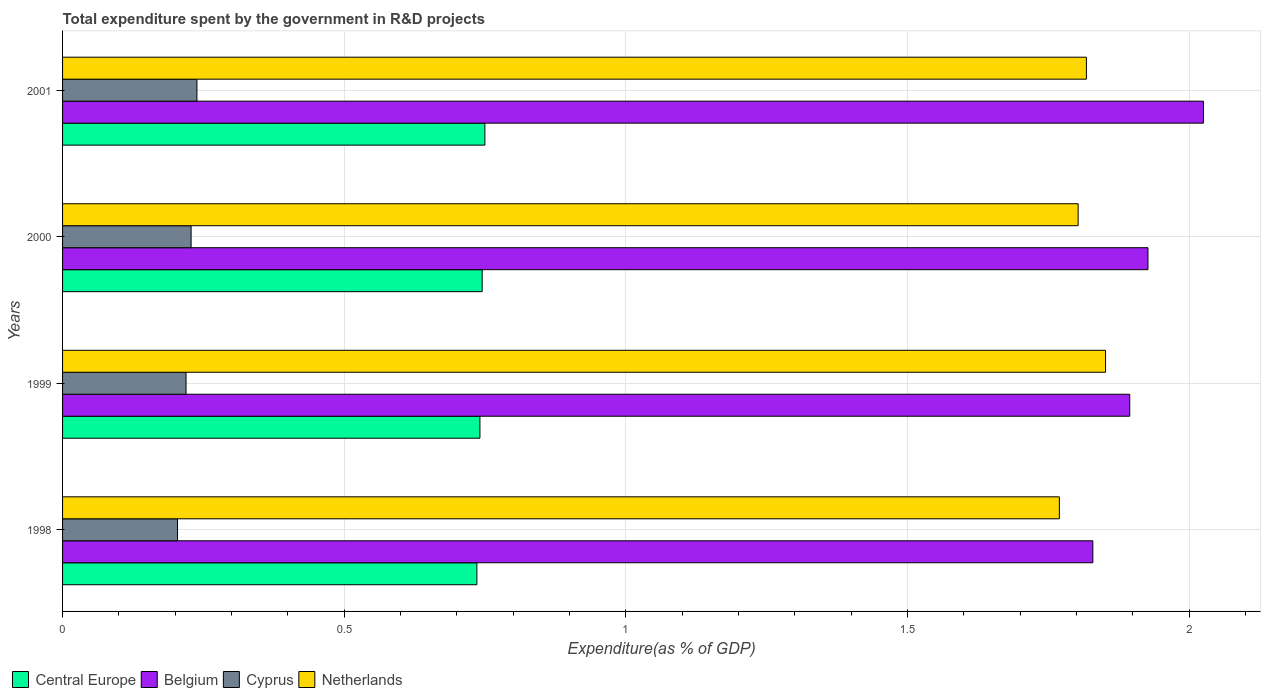Are the number of bars on each tick of the Y-axis equal?
Ensure brevity in your answer.  Yes. How many bars are there on the 3rd tick from the top?
Your answer should be very brief. 4. How many bars are there on the 1st tick from the bottom?
Your answer should be very brief. 4. What is the label of the 1st group of bars from the top?
Keep it short and to the point. 2001. In how many cases, is the number of bars for a given year not equal to the number of legend labels?
Ensure brevity in your answer.  0. What is the total expenditure spent by the government in R&D projects in Belgium in 2001?
Offer a terse response. 2.03. Across all years, what is the maximum total expenditure spent by the government in R&D projects in Netherlands?
Give a very brief answer. 1.85. Across all years, what is the minimum total expenditure spent by the government in R&D projects in Belgium?
Offer a very short reply. 1.83. What is the total total expenditure spent by the government in R&D projects in Belgium in the graph?
Ensure brevity in your answer.  7.68. What is the difference between the total expenditure spent by the government in R&D projects in Netherlands in 2000 and that in 2001?
Keep it short and to the point. -0.01. What is the difference between the total expenditure spent by the government in R&D projects in Cyprus in 1998 and the total expenditure spent by the government in R&D projects in Belgium in 1999?
Your response must be concise. -1.69. What is the average total expenditure spent by the government in R&D projects in Cyprus per year?
Your answer should be compact. 0.22. In the year 2001, what is the difference between the total expenditure spent by the government in R&D projects in Cyprus and total expenditure spent by the government in R&D projects in Belgium?
Your response must be concise. -1.79. In how many years, is the total expenditure spent by the government in R&D projects in Cyprus greater than 0.4 %?
Provide a succinct answer. 0. What is the ratio of the total expenditure spent by the government in R&D projects in Central Europe in 1998 to that in 1999?
Make the answer very short. 0.99. Is the total expenditure spent by the government in R&D projects in Central Europe in 1998 less than that in 1999?
Keep it short and to the point. Yes. Is the difference between the total expenditure spent by the government in R&D projects in Cyprus in 1998 and 2000 greater than the difference between the total expenditure spent by the government in R&D projects in Belgium in 1998 and 2000?
Ensure brevity in your answer.  Yes. What is the difference between the highest and the second highest total expenditure spent by the government in R&D projects in Cyprus?
Provide a succinct answer. 0.01. What is the difference between the highest and the lowest total expenditure spent by the government in R&D projects in Central Europe?
Your answer should be very brief. 0.01. In how many years, is the total expenditure spent by the government in R&D projects in Netherlands greater than the average total expenditure spent by the government in R&D projects in Netherlands taken over all years?
Ensure brevity in your answer.  2. Is the sum of the total expenditure spent by the government in R&D projects in Belgium in 1998 and 2000 greater than the maximum total expenditure spent by the government in R&D projects in Cyprus across all years?
Your answer should be very brief. Yes. What does the 4th bar from the top in 2000 represents?
Make the answer very short. Central Europe. What does the 2nd bar from the bottom in 1998 represents?
Keep it short and to the point. Belgium. How many bars are there?
Keep it short and to the point. 16. Does the graph contain any zero values?
Your response must be concise. No. Does the graph contain grids?
Offer a very short reply. Yes. Where does the legend appear in the graph?
Provide a succinct answer. Bottom left. What is the title of the graph?
Provide a succinct answer. Total expenditure spent by the government in R&D projects. Does "Central African Republic" appear as one of the legend labels in the graph?
Provide a succinct answer. No. What is the label or title of the X-axis?
Make the answer very short. Expenditure(as % of GDP). What is the label or title of the Y-axis?
Keep it short and to the point. Years. What is the Expenditure(as % of GDP) in Central Europe in 1998?
Your answer should be compact. 0.74. What is the Expenditure(as % of GDP) of Belgium in 1998?
Offer a terse response. 1.83. What is the Expenditure(as % of GDP) in Cyprus in 1998?
Offer a terse response. 0.2. What is the Expenditure(as % of GDP) of Netherlands in 1998?
Keep it short and to the point. 1.77. What is the Expenditure(as % of GDP) in Central Europe in 1999?
Your answer should be compact. 0.74. What is the Expenditure(as % of GDP) of Belgium in 1999?
Your answer should be compact. 1.89. What is the Expenditure(as % of GDP) in Cyprus in 1999?
Ensure brevity in your answer.  0.22. What is the Expenditure(as % of GDP) in Netherlands in 1999?
Your answer should be compact. 1.85. What is the Expenditure(as % of GDP) of Central Europe in 2000?
Ensure brevity in your answer.  0.74. What is the Expenditure(as % of GDP) in Belgium in 2000?
Provide a succinct answer. 1.93. What is the Expenditure(as % of GDP) in Cyprus in 2000?
Offer a terse response. 0.23. What is the Expenditure(as % of GDP) in Netherlands in 2000?
Offer a very short reply. 1.8. What is the Expenditure(as % of GDP) of Central Europe in 2001?
Your answer should be very brief. 0.75. What is the Expenditure(as % of GDP) of Belgium in 2001?
Provide a short and direct response. 2.03. What is the Expenditure(as % of GDP) in Cyprus in 2001?
Your answer should be compact. 0.24. What is the Expenditure(as % of GDP) in Netherlands in 2001?
Give a very brief answer. 1.82. Across all years, what is the maximum Expenditure(as % of GDP) of Central Europe?
Offer a terse response. 0.75. Across all years, what is the maximum Expenditure(as % of GDP) of Belgium?
Ensure brevity in your answer.  2.03. Across all years, what is the maximum Expenditure(as % of GDP) of Cyprus?
Make the answer very short. 0.24. Across all years, what is the maximum Expenditure(as % of GDP) in Netherlands?
Your response must be concise. 1.85. Across all years, what is the minimum Expenditure(as % of GDP) of Central Europe?
Keep it short and to the point. 0.74. Across all years, what is the minimum Expenditure(as % of GDP) in Belgium?
Provide a succinct answer. 1.83. Across all years, what is the minimum Expenditure(as % of GDP) of Cyprus?
Your answer should be very brief. 0.2. Across all years, what is the minimum Expenditure(as % of GDP) in Netherlands?
Ensure brevity in your answer.  1.77. What is the total Expenditure(as % of GDP) of Central Europe in the graph?
Your answer should be compact. 2.97. What is the total Expenditure(as % of GDP) of Belgium in the graph?
Offer a terse response. 7.68. What is the total Expenditure(as % of GDP) of Cyprus in the graph?
Your response must be concise. 0.89. What is the total Expenditure(as % of GDP) of Netherlands in the graph?
Make the answer very short. 7.24. What is the difference between the Expenditure(as % of GDP) in Central Europe in 1998 and that in 1999?
Your answer should be compact. -0.01. What is the difference between the Expenditure(as % of GDP) in Belgium in 1998 and that in 1999?
Your answer should be very brief. -0.07. What is the difference between the Expenditure(as % of GDP) in Cyprus in 1998 and that in 1999?
Give a very brief answer. -0.02. What is the difference between the Expenditure(as % of GDP) of Netherlands in 1998 and that in 1999?
Offer a very short reply. -0.08. What is the difference between the Expenditure(as % of GDP) in Central Europe in 1998 and that in 2000?
Your response must be concise. -0.01. What is the difference between the Expenditure(as % of GDP) in Belgium in 1998 and that in 2000?
Your answer should be compact. -0.1. What is the difference between the Expenditure(as % of GDP) in Cyprus in 1998 and that in 2000?
Your response must be concise. -0.02. What is the difference between the Expenditure(as % of GDP) of Netherlands in 1998 and that in 2000?
Make the answer very short. -0.03. What is the difference between the Expenditure(as % of GDP) in Central Europe in 1998 and that in 2001?
Your response must be concise. -0.01. What is the difference between the Expenditure(as % of GDP) of Belgium in 1998 and that in 2001?
Offer a terse response. -0.2. What is the difference between the Expenditure(as % of GDP) of Cyprus in 1998 and that in 2001?
Your answer should be very brief. -0.03. What is the difference between the Expenditure(as % of GDP) in Netherlands in 1998 and that in 2001?
Keep it short and to the point. -0.05. What is the difference between the Expenditure(as % of GDP) in Central Europe in 1999 and that in 2000?
Offer a terse response. -0. What is the difference between the Expenditure(as % of GDP) in Belgium in 1999 and that in 2000?
Offer a terse response. -0.03. What is the difference between the Expenditure(as % of GDP) in Cyprus in 1999 and that in 2000?
Ensure brevity in your answer.  -0.01. What is the difference between the Expenditure(as % of GDP) of Netherlands in 1999 and that in 2000?
Your answer should be compact. 0.05. What is the difference between the Expenditure(as % of GDP) of Central Europe in 1999 and that in 2001?
Give a very brief answer. -0.01. What is the difference between the Expenditure(as % of GDP) of Belgium in 1999 and that in 2001?
Give a very brief answer. -0.13. What is the difference between the Expenditure(as % of GDP) in Cyprus in 1999 and that in 2001?
Your response must be concise. -0.02. What is the difference between the Expenditure(as % of GDP) of Netherlands in 1999 and that in 2001?
Your answer should be very brief. 0.03. What is the difference between the Expenditure(as % of GDP) of Central Europe in 2000 and that in 2001?
Offer a very short reply. -0. What is the difference between the Expenditure(as % of GDP) in Belgium in 2000 and that in 2001?
Offer a very short reply. -0.1. What is the difference between the Expenditure(as % of GDP) in Cyprus in 2000 and that in 2001?
Offer a terse response. -0.01. What is the difference between the Expenditure(as % of GDP) in Netherlands in 2000 and that in 2001?
Give a very brief answer. -0.01. What is the difference between the Expenditure(as % of GDP) in Central Europe in 1998 and the Expenditure(as % of GDP) in Belgium in 1999?
Your answer should be compact. -1.16. What is the difference between the Expenditure(as % of GDP) of Central Europe in 1998 and the Expenditure(as % of GDP) of Cyprus in 1999?
Provide a short and direct response. 0.52. What is the difference between the Expenditure(as % of GDP) in Central Europe in 1998 and the Expenditure(as % of GDP) in Netherlands in 1999?
Your answer should be very brief. -1.12. What is the difference between the Expenditure(as % of GDP) in Belgium in 1998 and the Expenditure(as % of GDP) in Cyprus in 1999?
Your response must be concise. 1.61. What is the difference between the Expenditure(as % of GDP) in Belgium in 1998 and the Expenditure(as % of GDP) in Netherlands in 1999?
Provide a succinct answer. -0.02. What is the difference between the Expenditure(as % of GDP) of Cyprus in 1998 and the Expenditure(as % of GDP) of Netherlands in 1999?
Give a very brief answer. -1.65. What is the difference between the Expenditure(as % of GDP) in Central Europe in 1998 and the Expenditure(as % of GDP) in Belgium in 2000?
Your answer should be compact. -1.19. What is the difference between the Expenditure(as % of GDP) in Central Europe in 1998 and the Expenditure(as % of GDP) in Cyprus in 2000?
Ensure brevity in your answer.  0.51. What is the difference between the Expenditure(as % of GDP) in Central Europe in 1998 and the Expenditure(as % of GDP) in Netherlands in 2000?
Give a very brief answer. -1.07. What is the difference between the Expenditure(as % of GDP) of Belgium in 1998 and the Expenditure(as % of GDP) of Cyprus in 2000?
Ensure brevity in your answer.  1.6. What is the difference between the Expenditure(as % of GDP) in Belgium in 1998 and the Expenditure(as % of GDP) in Netherlands in 2000?
Give a very brief answer. 0.03. What is the difference between the Expenditure(as % of GDP) in Cyprus in 1998 and the Expenditure(as % of GDP) in Netherlands in 2000?
Ensure brevity in your answer.  -1.6. What is the difference between the Expenditure(as % of GDP) of Central Europe in 1998 and the Expenditure(as % of GDP) of Belgium in 2001?
Offer a terse response. -1.29. What is the difference between the Expenditure(as % of GDP) in Central Europe in 1998 and the Expenditure(as % of GDP) in Cyprus in 2001?
Provide a succinct answer. 0.5. What is the difference between the Expenditure(as % of GDP) in Central Europe in 1998 and the Expenditure(as % of GDP) in Netherlands in 2001?
Offer a terse response. -1.08. What is the difference between the Expenditure(as % of GDP) of Belgium in 1998 and the Expenditure(as % of GDP) of Cyprus in 2001?
Your response must be concise. 1.59. What is the difference between the Expenditure(as % of GDP) of Belgium in 1998 and the Expenditure(as % of GDP) of Netherlands in 2001?
Make the answer very short. 0.01. What is the difference between the Expenditure(as % of GDP) of Cyprus in 1998 and the Expenditure(as % of GDP) of Netherlands in 2001?
Make the answer very short. -1.61. What is the difference between the Expenditure(as % of GDP) in Central Europe in 1999 and the Expenditure(as % of GDP) in Belgium in 2000?
Your answer should be very brief. -1.19. What is the difference between the Expenditure(as % of GDP) in Central Europe in 1999 and the Expenditure(as % of GDP) in Cyprus in 2000?
Give a very brief answer. 0.51. What is the difference between the Expenditure(as % of GDP) in Central Europe in 1999 and the Expenditure(as % of GDP) in Netherlands in 2000?
Keep it short and to the point. -1.06. What is the difference between the Expenditure(as % of GDP) of Belgium in 1999 and the Expenditure(as % of GDP) of Cyprus in 2000?
Provide a succinct answer. 1.67. What is the difference between the Expenditure(as % of GDP) in Belgium in 1999 and the Expenditure(as % of GDP) in Netherlands in 2000?
Provide a short and direct response. 0.09. What is the difference between the Expenditure(as % of GDP) in Cyprus in 1999 and the Expenditure(as % of GDP) in Netherlands in 2000?
Your answer should be compact. -1.58. What is the difference between the Expenditure(as % of GDP) of Central Europe in 1999 and the Expenditure(as % of GDP) of Belgium in 2001?
Provide a short and direct response. -1.28. What is the difference between the Expenditure(as % of GDP) of Central Europe in 1999 and the Expenditure(as % of GDP) of Cyprus in 2001?
Give a very brief answer. 0.5. What is the difference between the Expenditure(as % of GDP) in Central Europe in 1999 and the Expenditure(as % of GDP) in Netherlands in 2001?
Give a very brief answer. -1.08. What is the difference between the Expenditure(as % of GDP) in Belgium in 1999 and the Expenditure(as % of GDP) in Cyprus in 2001?
Your response must be concise. 1.66. What is the difference between the Expenditure(as % of GDP) in Belgium in 1999 and the Expenditure(as % of GDP) in Netherlands in 2001?
Provide a short and direct response. 0.08. What is the difference between the Expenditure(as % of GDP) in Cyprus in 1999 and the Expenditure(as % of GDP) in Netherlands in 2001?
Your answer should be compact. -1.6. What is the difference between the Expenditure(as % of GDP) of Central Europe in 2000 and the Expenditure(as % of GDP) of Belgium in 2001?
Your response must be concise. -1.28. What is the difference between the Expenditure(as % of GDP) in Central Europe in 2000 and the Expenditure(as % of GDP) in Cyprus in 2001?
Offer a terse response. 0.51. What is the difference between the Expenditure(as % of GDP) of Central Europe in 2000 and the Expenditure(as % of GDP) of Netherlands in 2001?
Provide a short and direct response. -1.07. What is the difference between the Expenditure(as % of GDP) in Belgium in 2000 and the Expenditure(as % of GDP) in Cyprus in 2001?
Ensure brevity in your answer.  1.69. What is the difference between the Expenditure(as % of GDP) in Belgium in 2000 and the Expenditure(as % of GDP) in Netherlands in 2001?
Offer a very short reply. 0.11. What is the difference between the Expenditure(as % of GDP) in Cyprus in 2000 and the Expenditure(as % of GDP) in Netherlands in 2001?
Your response must be concise. -1.59. What is the average Expenditure(as % of GDP) in Central Europe per year?
Provide a short and direct response. 0.74. What is the average Expenditure(as % of GDP) in Belgium per year?
Your response must be concise. 1.92. What is the average Expenditure(as % of GDP) of Cyprus per year?
Give a very brief answer. 0.22. What is the average Expenditure(as % of GDP) of Netherlands per year?
Make the answer very short. 1.81. In the year 1998, what is the difference between the Expenditure(as % of GDP) in Central Europe and Expenditure(as % of GDP) in Belgium?
Your answer should be very brief. -1.09. In the year 1998, what is the difference between the Expenditure(as % of GDP) in Central Europe and Expenditure(as % of GDP) in Cyprus?
Make the answer very short. 0.53. In the year 1998, what is the difference between the Expenditure(as % of GDP) of Central Europe and Expenditure(as % of GDP) of Netherlands?
Ensure brevity in your answer.  -1.03. In the year 1998, what is the difference between the Expenditure(as % of GDP) of Belgium and Expenditure(as % of GDP) of Cyprus?
Keep it short and to the point. 1.62. In the year 1998, what is the difference between the Expenditure(as % of GDP) of Belgium and Expenditure(as % of GDP) of Netherlands?
Provide a succinct answer. 0.06. In the year 1998, what is the difference between the Expenditure(as % of GDP) in Cyprus and Expenditure(as % of GDP) in Netherlands?
Make the answer very short. -1.57. In the year 1999, what is the difference between the Expenditure(as % of GDP) of Central Europe and Expenditure(as % of GDP) of Belgium?
Provide a short and direct response. -1.15. In the year 1999, what is the difference between the Expenditure(as % of GDP) of Central Europe and Expenditure(as % of GDP) of Cyprus?
Offer a terse response. 0.52. In the year 1999, what is the difference between the Expenditure(as % of GDP) in Central Europe and Expenditure(as % of GDP) in Netherlands?
Make the answer very short. -1.11. In the year 1999, what is the difference between the Expenditure(as % of GDP) of Belgium and Expenditure(as % of GDP) of Cyprus?
Your answer should be compact. 1.68. In the year 1999, what is the difference between the Expenditure(as % of GDP) in Belgium and Expenditure(as % of GDP) in Netherlands?
Offer a very short reply. 0.04. In the year 1999, what is the difference between the Expenditure(as % of GDP) of Cyprus and Expenditure(as % of GDP) of Netherlands?
Offer a terse response. -1.63. In the year 2000, what is the difference between the Expenditure(as % of GDP) in Central Europe and Expenditure(as % of GDP) in Belgium?
Your response must be concise. -1.18. In the year 2000, what is the difference between the Expenditure(as % of GDP) of Central Europe and Expenditure(as % of GDP) of Cyprus?
Keep it short and to the point. 0.52. In the year 2000, what is the difference between the Expenditure(as % of GDP) of Central Europe and Expenditure(as % of GDP) of Netherlands?
Provide a succinct answer. -1.06. In the year 2000, what is the difference between the Expenditure(as % of GDP) in Belgium and Expenditure(as % of GDP) in Cyprus?
Provide a short and direct response. 1.7. In the year 2000, what is the difference between the Expenditure(as % of GDP) of Belgium and Expenditure(as % of GDP) of Netherlands?
Provide a succinct answer. 0.12. In the year 2000, what is the difference between the Expenditure(as % of GDP) in Cyprus and Expenditure(as % of GDP) in Netherlands?
Provide a short and direct response. -1.57. In the year 2001, what is the difference between the Expenditure(as % of GDP) in Central Europe and Expenditure(as % of GDP) in Belgium?
Your answer should be compact. -1.28. In the year 2001, what is the difference between the Expenditure(as % of GDP) of Central Europe and Expenditure(as % of GDP) of Cyprus?
Your response must be concise. 0.51. In the year 2001, what is the difference between the Expenditure(as % of GDP) of Central Europe and Expenditure(as % of GDP) of Netherlands?
Make the answer very short. -1.07. In the year 2001, what is the difference between the Expenditure(as % of GDP) of Belgium and Expenditure(as % of GDP) of Cyprus?
Offer a very short reply. 1.79. In the year 2001, what is the difference between the Expenditure(as % of GDP) in Belgium and Expenditure(as % of GDP) in Netherlands?
Give a very brief answer. 0.21. In the year 2001, what is the difference between the Expenditure(as % of GDP) of Cyprus and Expenditure(as % of GDP) of Netherlands?
Offer a very short reply. -1.58. What is the ratio of the Expenditure(as % of GDP) in Belgium in 1998 to that in 1999?
Your answer should be very brief. 0.97. What is the ratio of the Expenditure(as % of GDP) of Cyprus in 1998 to that in 1999?
Offer a very short reply. 0.93. What is the ratio of the Expenditure(as % of GDP) of Netherlands in 1998 to that in 1999?
Make the answer very short. 0.96. What is the ratio of the Expenditure(as % of GDP) in Central Europe in 1998 to that in 2000?
Your answer should be compact. 0.99. What is the ratio of the Expenditure(as % of GDP) of Belgium in 1998 to that in 2000?
Offer a very short reply. 0.95. What is the ratio of the Expenditure(as % of GDP) in Cyprus in 1998 to that in 2000?
Offer a terse response. 0.89. What is the ratio of the Expenditure(as % of GDP) of Netherlands in 1998 to that in 2000?
Your response must be concise. 0.98. What is the ratio of the Expenditure(as % of GDP) of Central Europe in 1998 to that in 2001?
Ensure brevity in your answer.  0.98. What is the ratio of the Expenditure(as % of GDP) in Belgium in 1998 to that in 2001?
Give a very brief answer. 0.9. What is the ratio of the Expenditure(as % of GDP) in Cyprus in 1998 to that in 2001?
Your answer should be very brief. 0.86. What is the ratio of the Expenditure(as % of GDP) of Netherlands in 1998 to that in 2001?
Provide a succinct answer. 0.97. What is the ratio of the Expenditure(as % of GDP) of Belgium in 1999 to that in 2000?
Your answer should be compact. 0.98. What is the ratio of the Expenditure(as % of GDP) of Cyprus in 1999 to that in 2000?
Keep it short and to the point. 0.96. What is the ratio of the Expenditure(as % of GDP) of Netherlands in 1999 to that in 2000?
Your answer should be compact. 1.03. What is the ratio of the Expenditure(as % of GDP) in Central Europe in 1999 to that in 2001?
Your answer should be very brief. 0.99. What is the ratio of the Expenditure(as % of GDP) of Belgium in 1999 to that in 2001?
Keep it short and to the point. 0.94. What is the ratio of the Expenditure(as % of GDP) in Cyprus in 1999 to that in 2001?
Your response must be concise. 0.92. What is the ratio of the Expenditure(as % of GDP) of Netherlands in 1999 to that in 2001?
Your answer should be compact. 1.02. What is the ratio of the Expenditure(as % of GDP) of Central Europe in 2000 to that in 2001?
Keep it short and to the point. 0.99. What is the ratio of the Expenditure(as % of GDP) in Belgium in 2000 to that in 2001?
Provide a short and direct response. 0.95. What is the ratio of the Expenditure(as % of GDP) of Cyprus in 2000 to that in 2001?
Ensure brevity in your answer.  0.96. What is the ratio of the Expenditure(as % of GDP) in Netherlands in 2000 to that in 2001?
Your answer should be compact. 0.99. What is the difference between the highest and the second highest Expenditure(as % of GDP) in Central Europe?
Your answer should be very brief. 0. What is the difference between the highest and the second highest Expenditure(as % of GDP) of Belgium?
Ensure brevity in your answer.  0.1. What is the difference between the highest and the second highest Expenditure(as % of GDP) in Cyprus?
Make the answer very short. 0.01. What is the difference between the highest and the second highest Expenditure(as % of GDP) in Netherlands?
Offer a very short reply. 0.03. What is the difference between the highest and the lowest Expenditure(as % of GDP) in Central Europe?
Offer a very short reply. 0.01. What is the difference between the highest and the lowest Expenditure(as % of GDP) in Belgium?
Give a very brief answer. 0.2. What is the difference between the highest and the lowest Expenditure(as % of GDP) of Cyprus?
Provide a succinct answer. 0.03. What is the difference between the highest and the lowest Expenditure(as % of GDP) in Netherlands?
Provide a short and direct response. 0.08. 